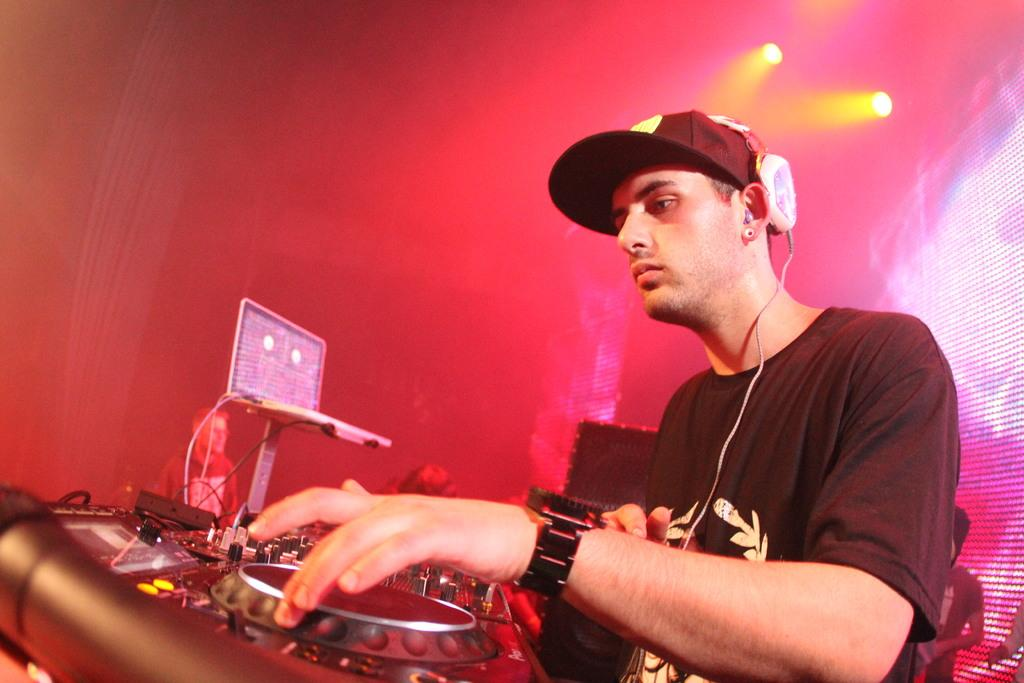What is the man in the image doing? The man is operating a music controller in the image. Can you describe the man's attire in the image? The man is wearing a cap and headphones in the image. What can be seen in the background of the image? There are lights visible in the image. What type of zephyr can be seen blowing through the man's hair in the image? There is no zephyr present in the image, and the man's hair is not visible. What view can be seen from the window in the image? There is no window present in the image. 